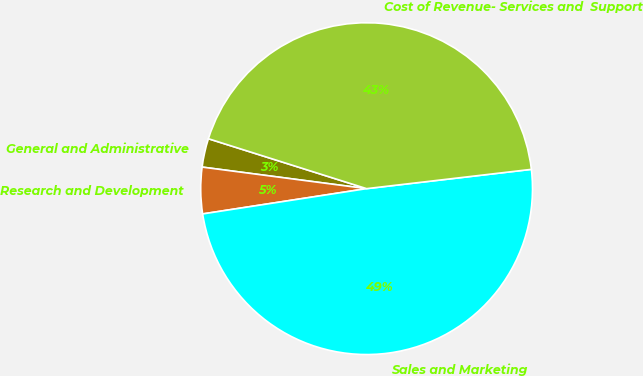Convert chart. <chart><loc_0><loc_0><loc_500><loc_500><pie_chart><fcel>General and Administrative<fcel>Research and Development<fcel>Sales and Marketing<fcel>Cost of Revenue- Services and  Support<nl><fcel>2.79%<fcel>4.51%<fcel>49.42%<fcel>43.28%<nl></chart> 